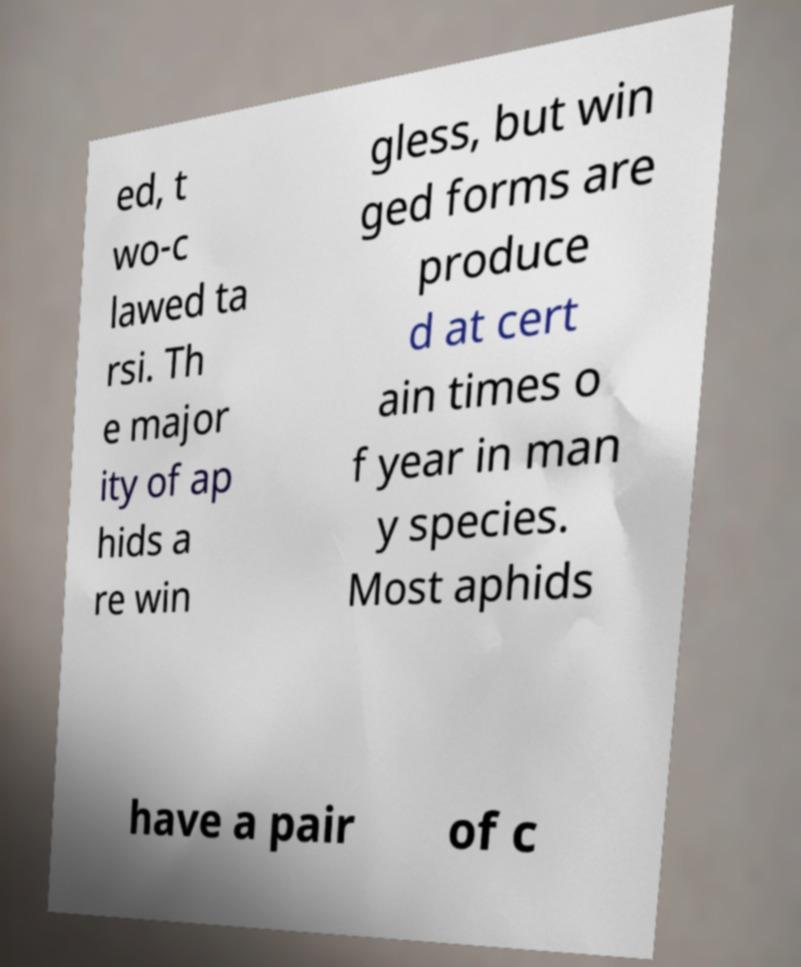Please identify and transcribe the text found in this image. ed, t wo-c lawed ta rsi. Th e major ity of ap hids a re win gless, but win ged forms are produce d at cert ain times o f year in man y species. Most aphids have a pair of c 